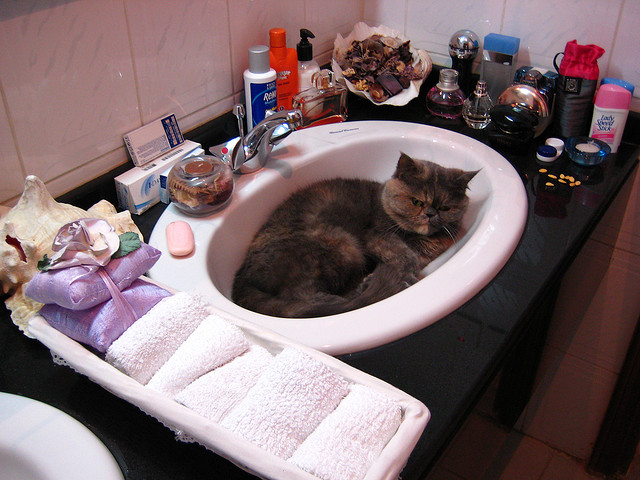How does the cat being in the sink affect the use of the bathroom? With the cat occupying the sink, normal bathroom activities like washing hands or brushing teeth would be difficult without disturbing the feline, potentially making the bathroom less functional for the time being. Is there anything that the cat might find interesting around it? Cats are naturally curious, so the variety of small items on the sink countertop, such as the bottle caps and toiletry containers, might attract the cat's attention for play or investigation. 